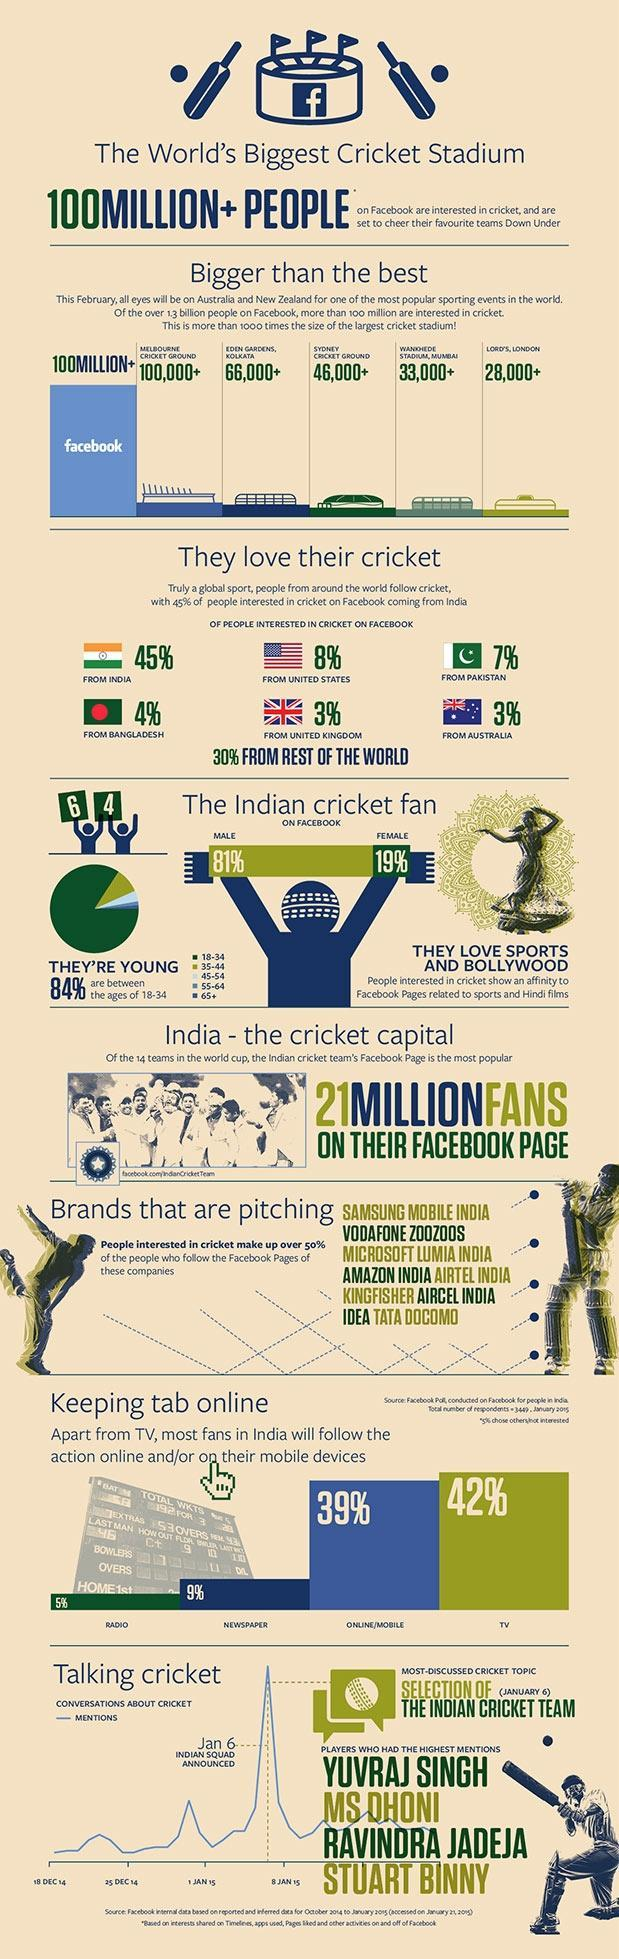Which is the second most used medium by viewers to follow cricket?
Answer the question with a short phrase. Online/Mobile What is the capacity of the Eden Gardens, Kolkata, 100,000+, 66,000+, or 46,000+? 66,000+ What is the percentage of British and Aussies following cricket on Facebook? 3% 